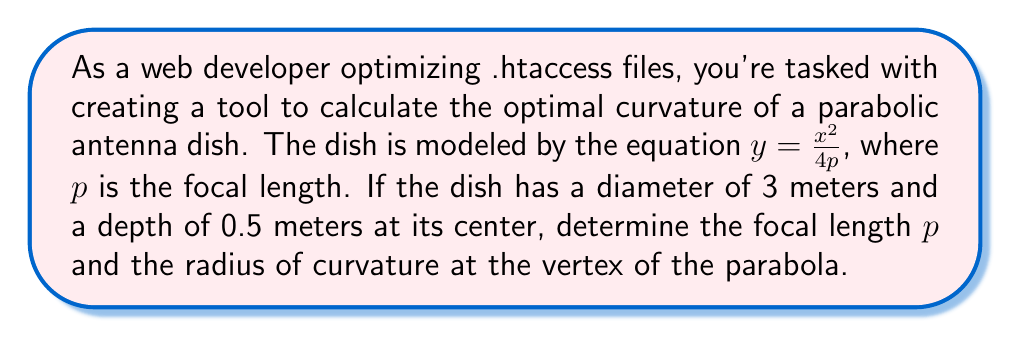Solve this math problem. Let's approach this step-by-step:

1) For a parabola $y = \frac{x^2}{4p}$, the focal length is $p$.

2) We know the dish has a diameter of 3 meters, so its radius is 1.5 meters. At the edge of the dish, $x = 1.5$ and $y = 0.5$ (the depth at the center).

3) Substituting these values into the equation of the parabola:

   $$0.5 = \frac{(1.5)^2}{4p}$$

4) Solving for $p$:
   
   $$p = \frac{(1.5)^2}{4(0.5)} = \frac{2.25}{2} = 1.125$$

5) The focal length $p$ is 1.125 meters.

6) To find the radius of curvature at the vertex, we use the formula:

   $$R = 2p$$

7) Substituting our value for $p$:

   $$R = 2(1.125) = 2.25$$

Therefore, the radius of curvature at the vertex is 2.25 meters.

[asy]
import graph;
size(200,200);
real f(real x) {return x^2/(4*1.125);}
draw(graph(f,-1.5,1.5));
draw((-1.5,0)--(1.5,0),arrow=Arrow(TeXHead));
draw((0,0)--(0,0.6),arrow=Arrow(TeXHead));
label("x",(-1.5,0),SW);
label("y",(0,0.6),NE);
dot((0,0));
dot((1.5,0.5));
dot((-1.5,0.5));
label("1.5m",(1.5,0),S);
label("0.5m",(1.5,0.5),NE);
[/asy]
Answer: The focal length $p$ is 1.125 meters, and the radius of curvature at the vertex is 2.25 meters. 